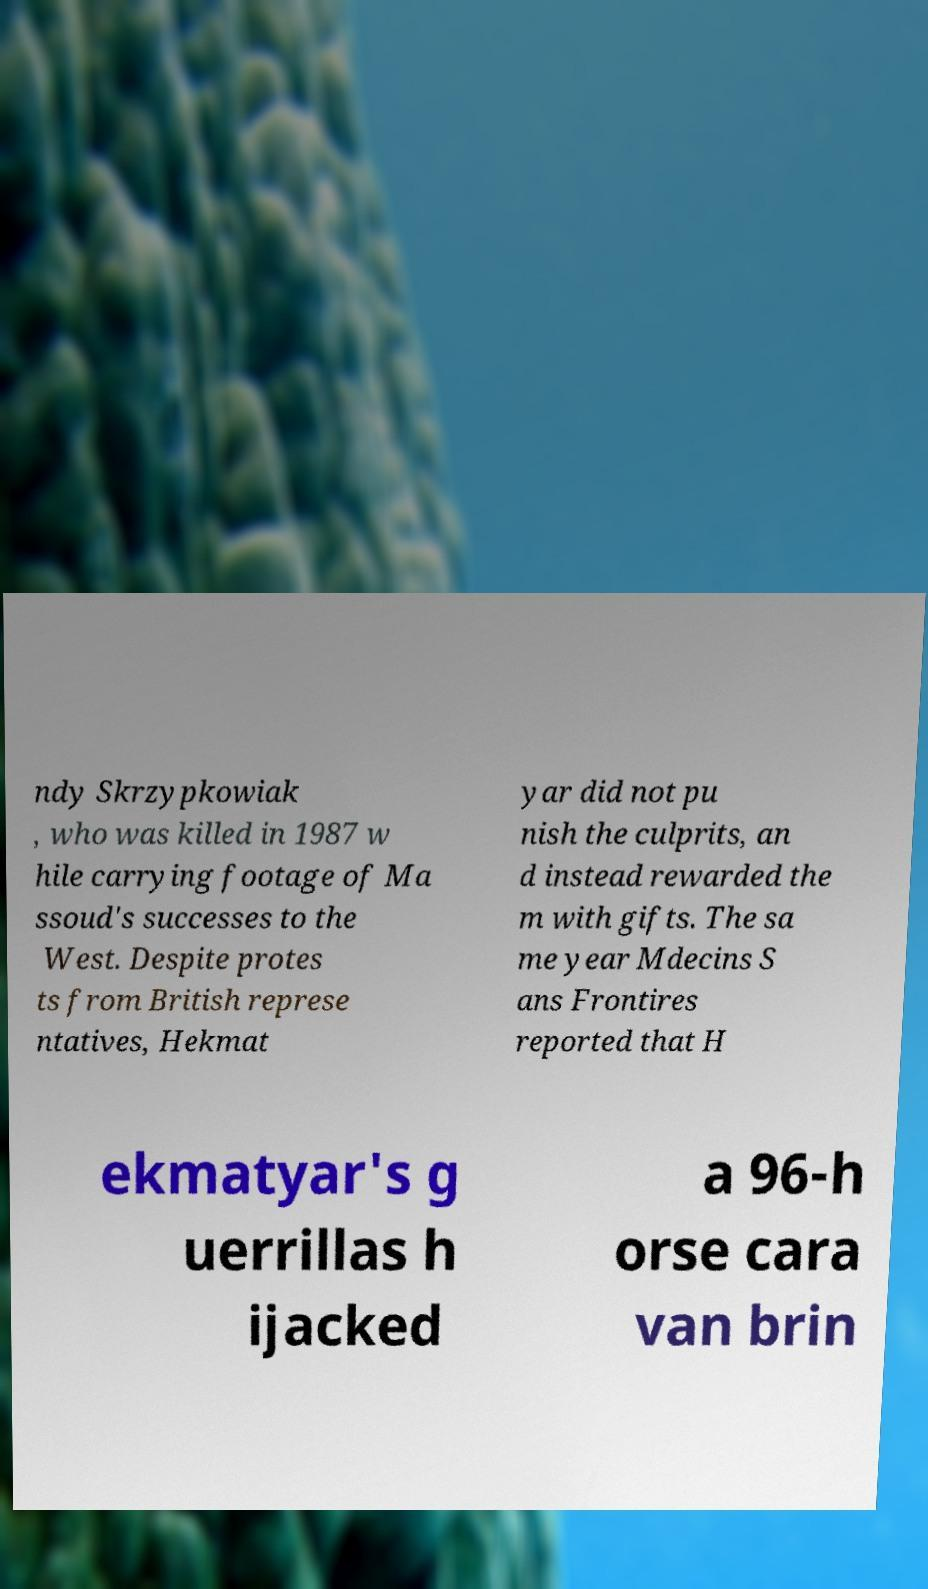I need the written content from this picture converted into text. Can you do that? ndy Skrzypkowiak , who was killed in 1987 w hile carrying footage of Ma ssoud's successes to the West. Despite protes ts from British represe ntatives, Hekmat yar did not pu nish the culprits, an d instead rewarded the m with gifts. The sa me year Mdecins S ans Frontires reported that H ekmatyar's g uerrillas h ijacked a 96-h orse cara van brin 